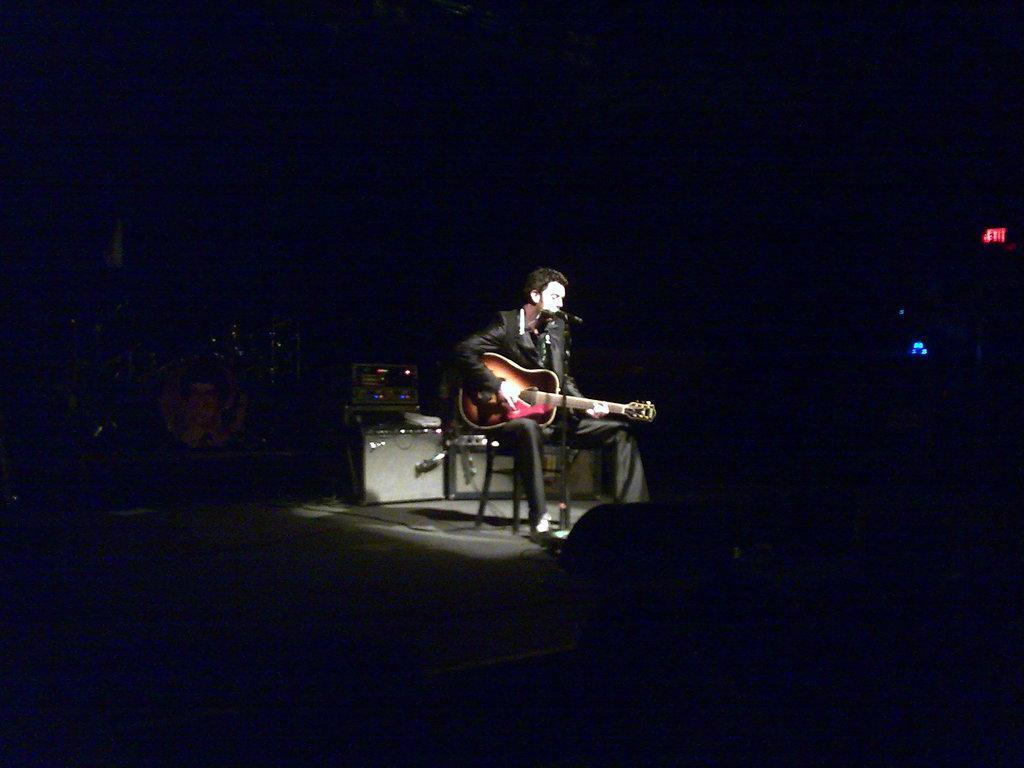Describe this image in one or two sentences. In the center we can see one person sitting on the chair and holding guitar. In front there is a microphone. In the background we can see photo frames,speaker and few musical instruments. 